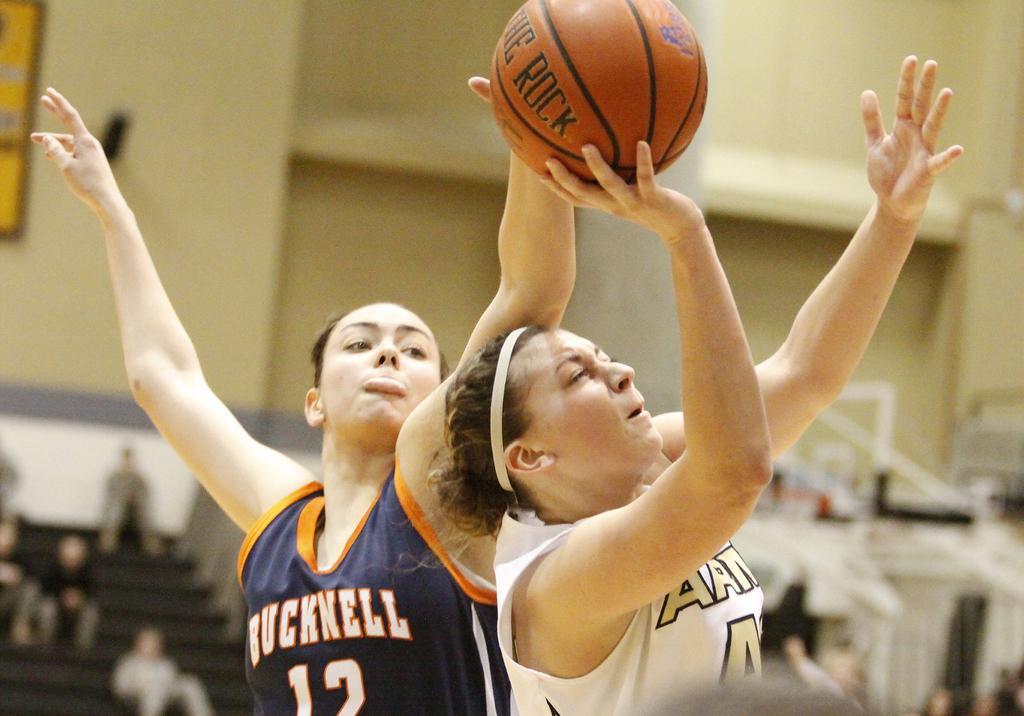Can you describe this image briefly? In this picture we can see two men playing basketball. The background is blurred. 